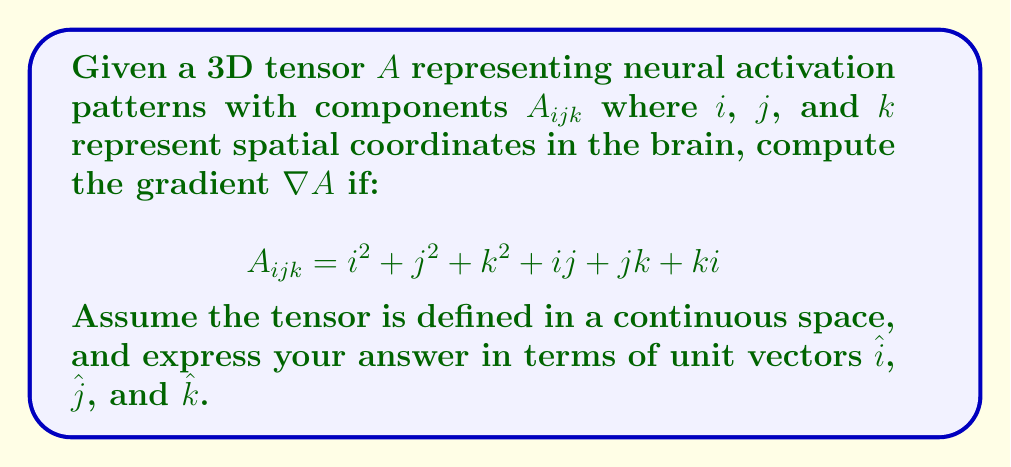Give your solution to this math problem. To compute the gradient of the tensor $A$, we need to calculate the partial derivatives with respect to each spatial coordinate:

1. Partial derivative with respect to $i$:
   $$\frac{\partial A_{ijk}}{\partial i} = 2i + j + k$$

2. Partial derivative with respect to $j$:
   $$\frac{\partial A_{ijk}}{\partial j} = 2j + i + k$$

3. Partial derivative with respect to $k$:
   $$\frac{\partial A_{ijk}}{\partial k} = 2k + j + i$$

The gradient $\nabla A$ is a vector field whose components are these partial derivatives:

$$\nabla A = \frac{\partial A_{ijk}}{\partial i}\hat{i} + \frac{\partial A_{ijk}}{\partial j}\hat{j} + \frac{\partial A_{ijk}}{\partial k}\hat{k}$$

Substituting the calculated partial derivatives:

$$\nabla A = (2i + j + k)\hat{i} + (2j + i + k)\hat{j} + (2k + j + i)\hat{k}$$

This expression represents the gradient of the neural activation pattern tensor $A$ at any point $(i, j, k)$ in the brain's spatial coordinates.
Answer: $\nabla A = (2i + j + k)\hat{i} + (2j + i + k)\hat{j} + (2k + j + i)\hat{k}$ 